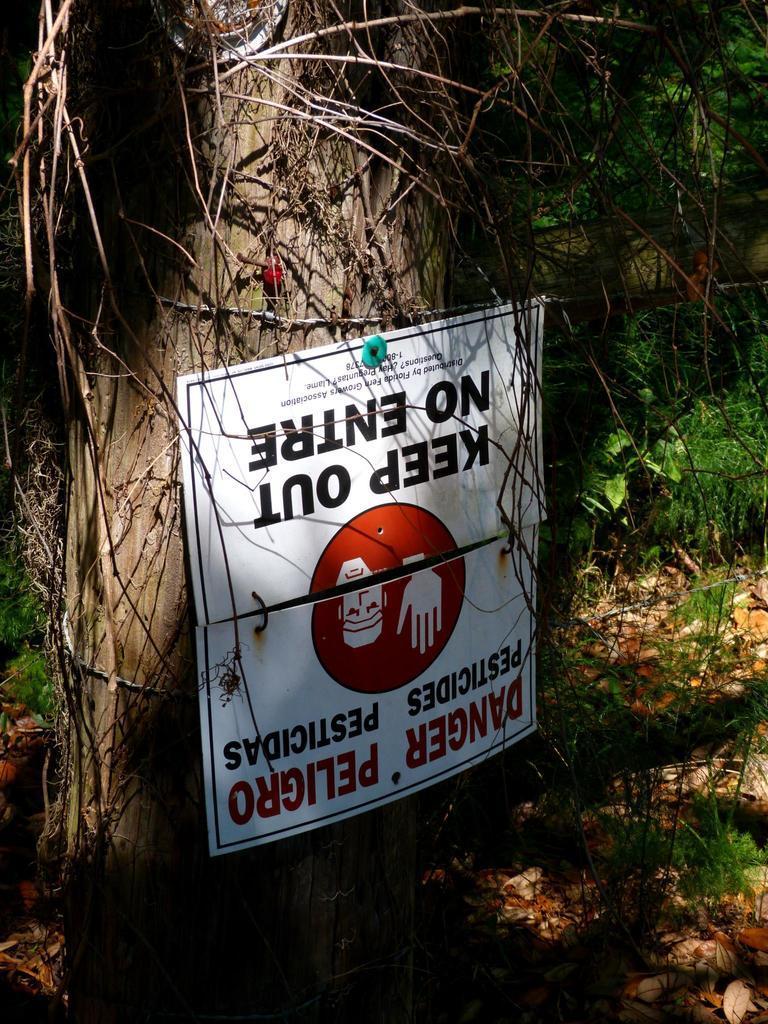Could you give a brief overview of what you see in this image? In the center of the image there is a poster on the tree trunk. At the bottom of the image there are dried leaves. 